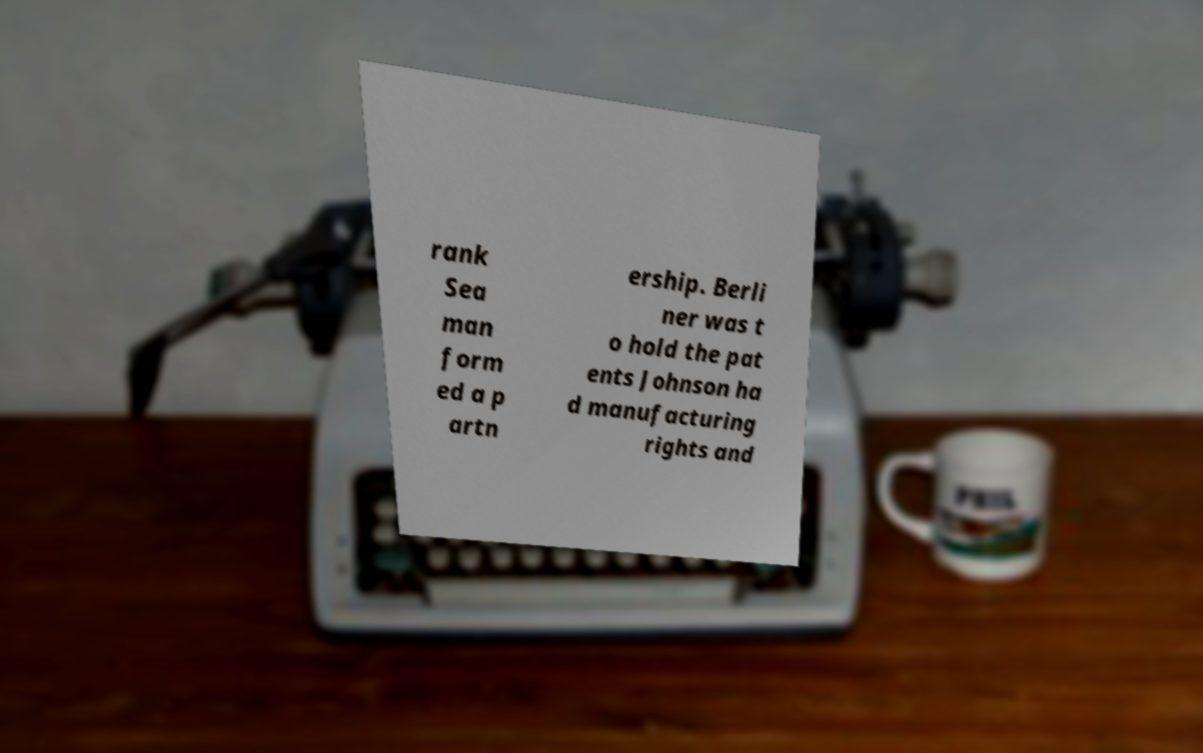For documentation purposes, I need the text within this image transcribed. Could you provide that? rank Sea man form ed a p artn ership. Berli ner was t o hold the pat ents Johnson ha d manufacturing rights and 